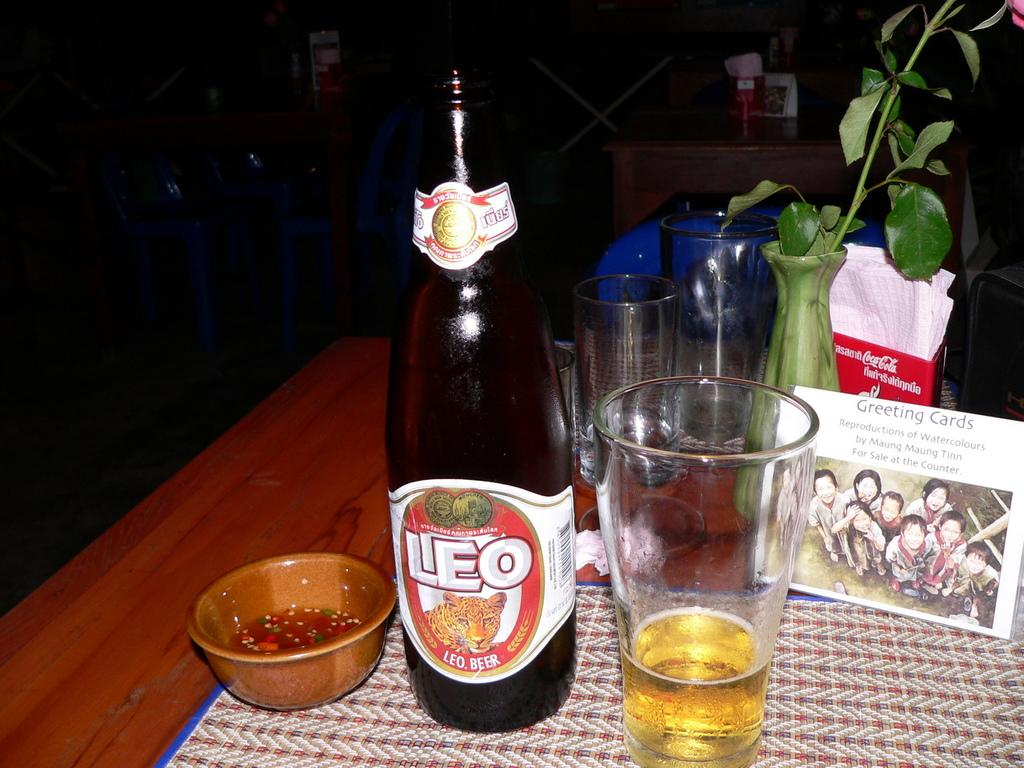<image>
Write a terse but informative summary of the picture. A small table with a bottle of leo beer and an almost finished glass of beer. 